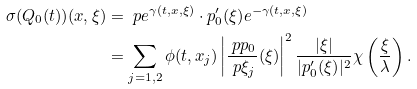<formula> <loc_0><loc_0><loc_500><loc_500>\sigma ( Q _ { 0 } ( t ) ) ( x , \xi ) & = \ p { e ^ { \gamma ( t , x , \xi ) } } \cdot { p _ { 0 } ^ { \prime } ( \xi ) } e ^ { - \gamma ( t , x , \xi ) } \\ & = \sum _ { j = 1 , 2 } \phi ( t , x _ { j } ) \left | \frac { \ p { p _ { 0 } } } { \ p \xi _ { j } } ( \xi ) \right | ^ { 2 } \frac { | \xi | } { | { p _ { 0 } ^ { \prime } ( \xi ) } | ^ { 2 } } \chi \left ( \frac { \xi } { \lambda } \right ) .</formula> 